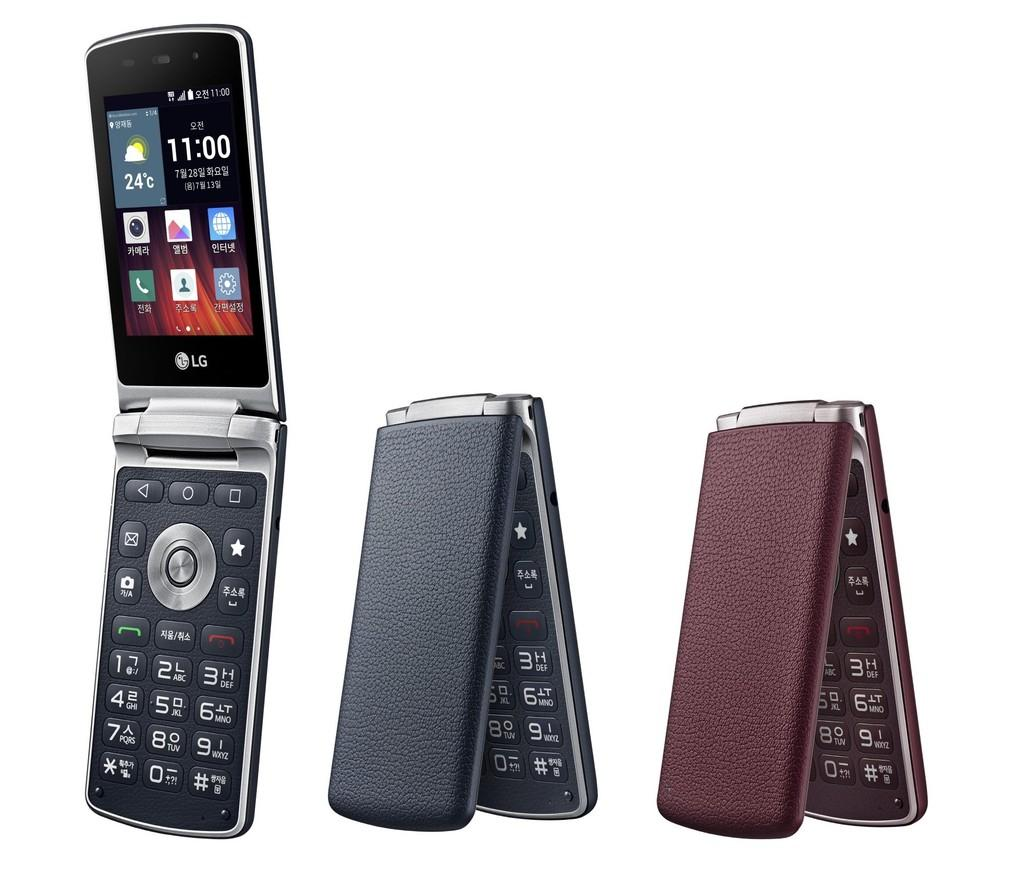<image>
Create a compact narrative representing the image presented. An LG brand flip phone is open and displaying a time of 11:00 on its screen. 